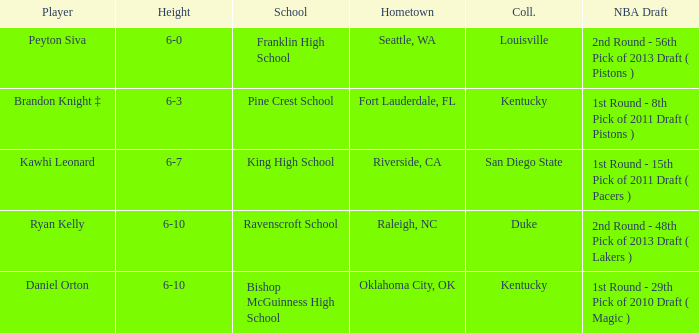How tall is Daniel Orton? 6-10. Could you parse the entire table? {'header': ['Player', 'Height', 'School', 'Hometown', 'Coll.', 'NBA Draft'], 'rows': [['Peyton Siva', '6-0', 'Franklin High School', 'Seattle, WA', 'Louisville', '2nd Round - 56th Pick of 2013 Draft ( Pistons )'], ['Brandon Knight ‡', '6-3', 'Pine Crest School', 'Fort Lauderdale, FL', 'Kentucky', '1st Round - 8th Pick of 2011 Draft ( Pistons )'], ['Kawhi Leonard', '6-7', 'King High School', 'Riverside, CA', 'San Diego State', '1st Round - 15th Pick of 2011 Draft ( Pacers )'], ['Ryan Kelly', '6-10', 'Ravenscroft School', 'Raleigh, NC', 'Duke', '2nd Round - 48th Pick of 2013 Draft ( Lakers )'], ['Daniel Orton', '6-10', 'Bishop McGuinness High School', 'Oklahoma City, OK', 'Kentucky', '1st Round - 29th Pick of 2010 Draft ( Magic )']]} 